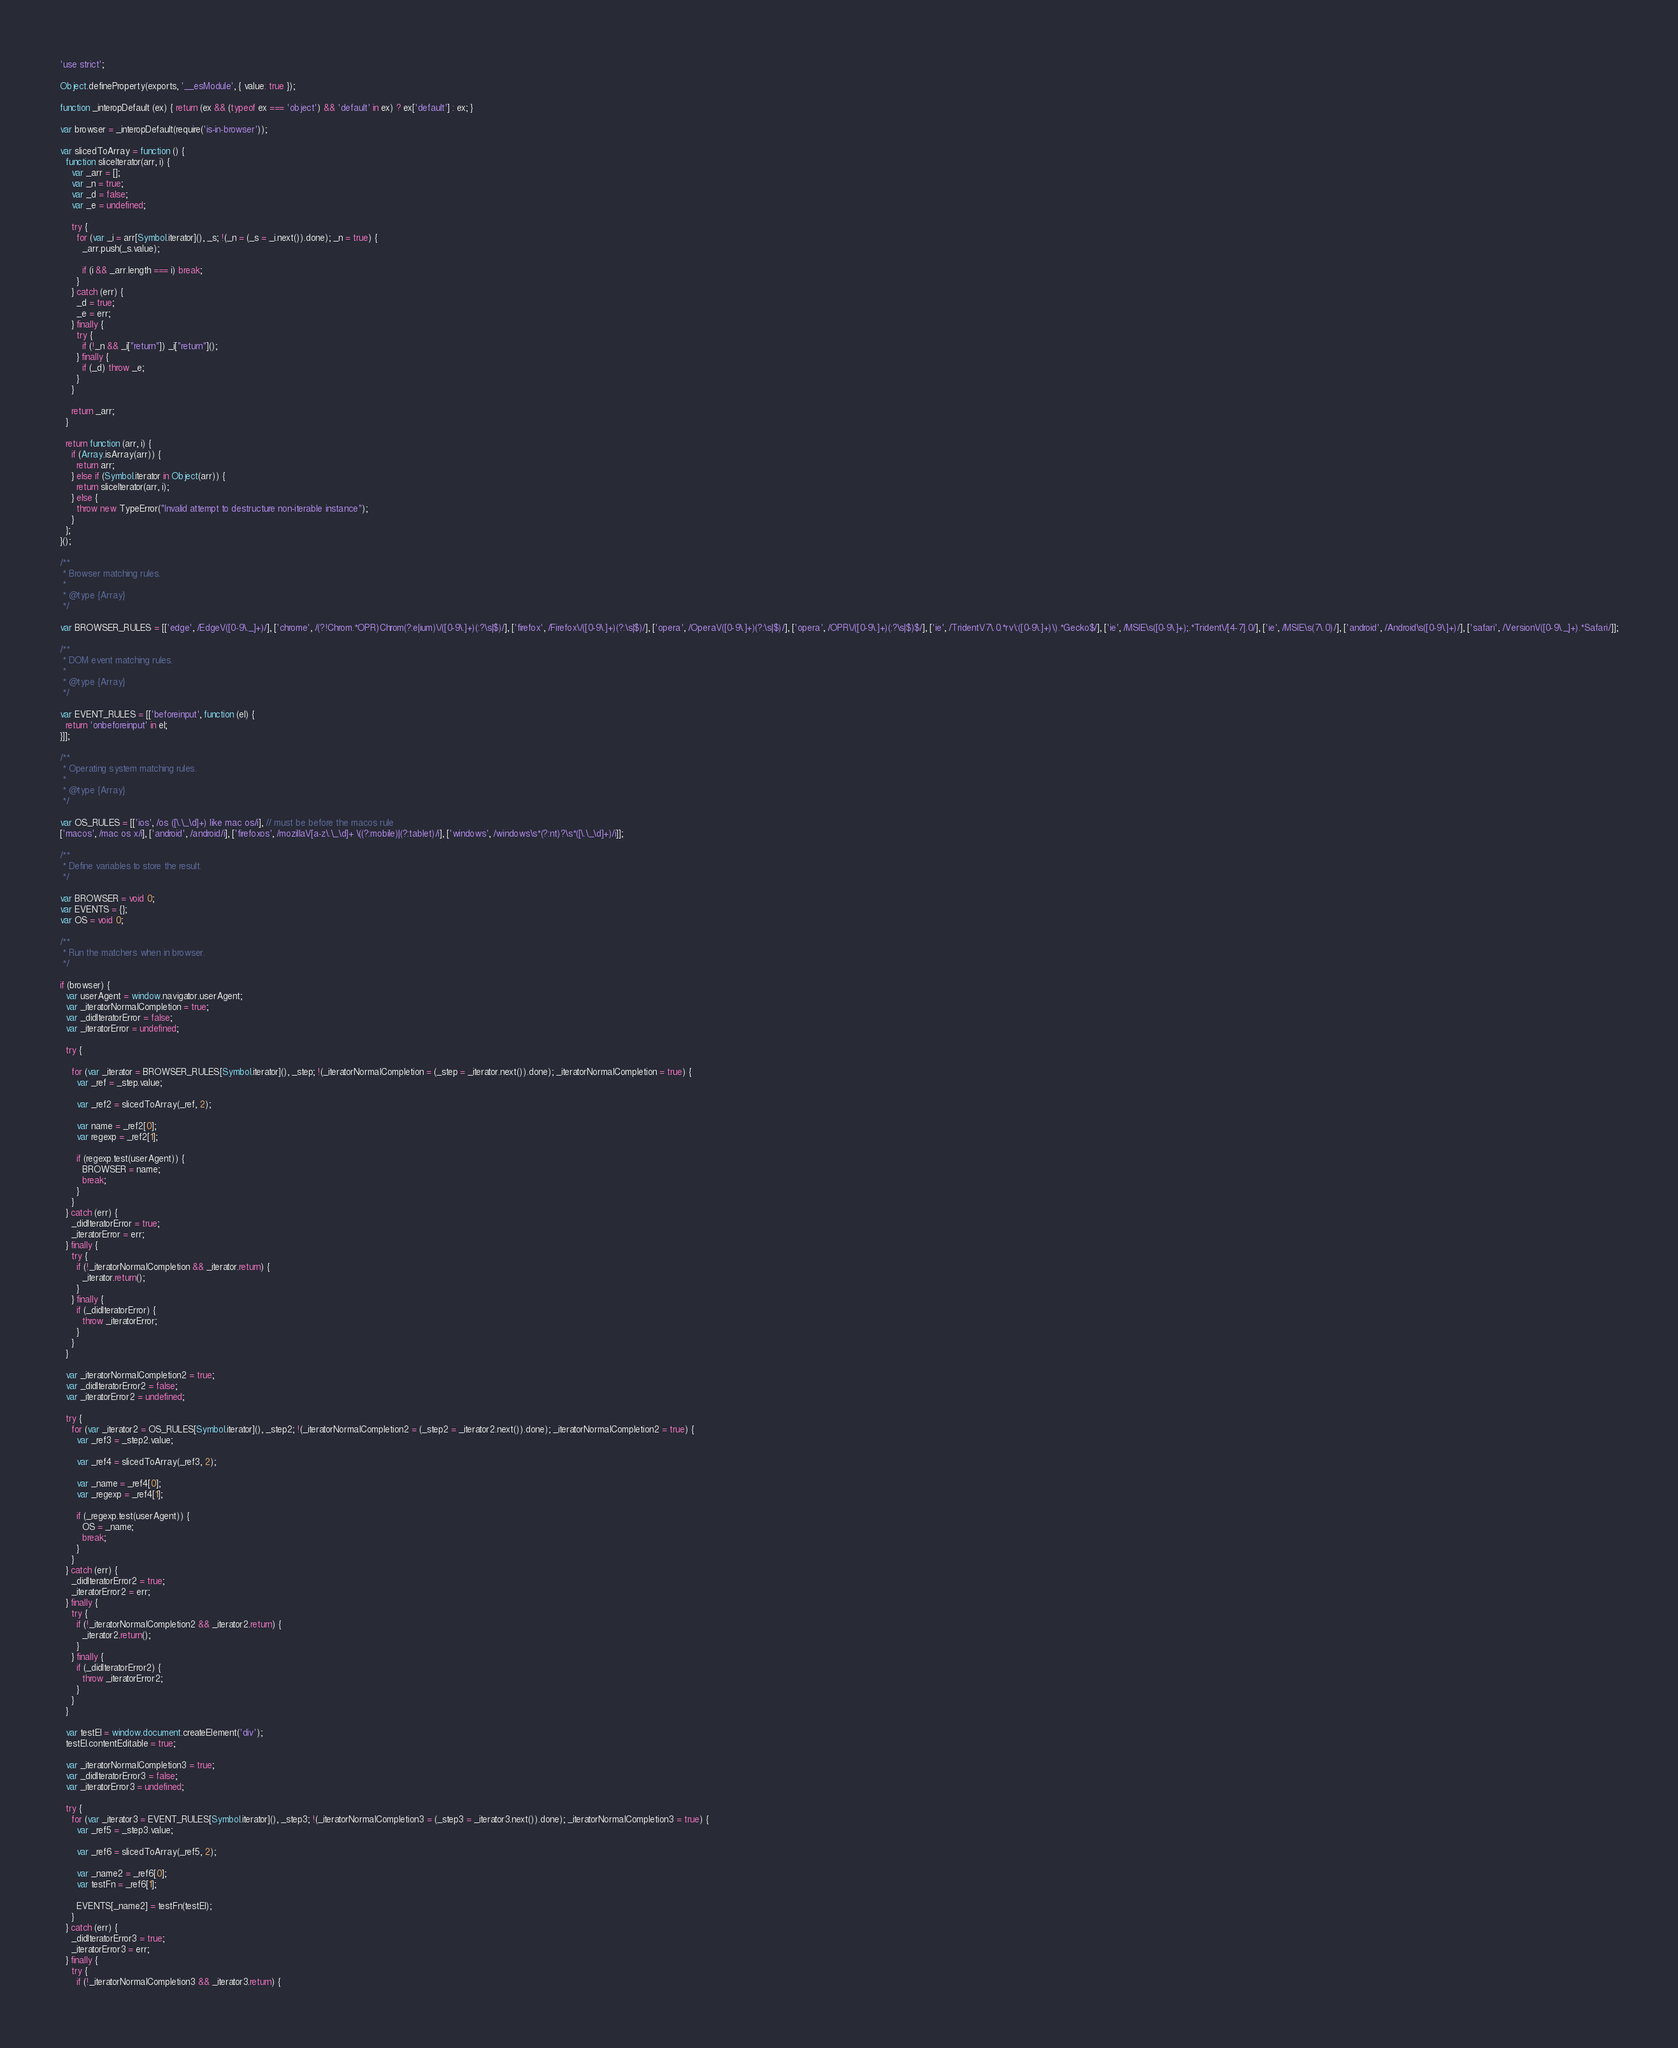<code> <loc_0><loc_0><loc_500><loc_500><_JavaScript_>'use strict';

Object.defineProperty(exports, '__esModule', { value: true });

function _interopDefault (ex) { return (ex && (typeof ex === 'object') && 'default' in ex) ? ex['default'] : ex; }

var browser = _interopDefault(require('is-in-browser'));

var slicedToArray = function () {
  function sliceIterator(arr, i) {
    var _arr = [];
    var _n = true;
    var _d = false;
    var _e = undefined;

    try {
      for (var _i = arr[Symbol.iterator](), _s; !(_n = (_s = _i.next()).done); _n = true) {
        _arr.push(_s.value);

        if (i && _arr.length === i) break;
      }
    } catch (err) {
      _d = true;
      _e = err;
    } finally {
      try {
        if (!_n && _i["return"]) _i["return"]();
      } finally {
        if (_d) throw _e;
      }
    }

    return _arr;
  }

  return function (arr, i) {
    if (Array.isArray(arr)) {
      return arr;
    } else if (Symbol.iterator in Object(arr)) {
      return sliceIterator(arr, i);
    } else {
      throw new TypeError("Invalid attempt to destructure non-iterable instance");
    }
  };
}();

/**
 * Browser matching rules.
 *
 * @type {Array}
 */

var BROWSER_RULES = [['edge', /Edge\/([0-9\._]+)/], ['chrome', /(?!Chrom.*OPR)Chrom(?:e|ium)\/([0-9\.]+)(:?\s|$)/], ['firefox', /Firefox\/([0-9\.]+)(?:\s|$)/], ['opera', /Opera\/([0-9\.]+)(?:\s|$)/], ['opera', /OPR\/([0-9\.]+)(:?\s|$)$/], ['ie', /Trident\/7\.0.*rv\:([0-9\.]+)\).*Gecko$/], ['ie', /MSIE\s([0-9\.]+);.*Trident\/[4-7].0/], ['ie', /MSIE\s(7\.0)/], ['android', /Android\s([0-9\.]+)/], ['safari', /Version\/([0-9\._]+).*Safari/]];

/**
 * DOM event matching rules.
 *
 * @type {Array}
 */

var EVENT_RULES = [['beforeinput', function (el) {
  return 'onbeforeinput' in el;
}]];

/**
 * Operating system matching rules.
 *
 * @type {Array}
 */

var OS_RULES = [['ios', /os ([\.\_\d]+) like mac os/i], // must be before the macos rule
['macos', /mac os x/i], ['android', /android/i], ['firefoxos', /mozilla\/[a-z\.\_\d]+ \((?:mobile)|(?:tablet)/i], ['windows', /windows\s*(?:nt)?\s*([\.\_\d]+)/i]];

/**
 * Define variables to store the result.
 */

var BROWSER = void 0;
var EVENTS = {};
var OS = void 0;

/**
 * Run the matchers when in browser.
 */

if (browser) {
  var userAgent = window.navigator.userAgent;
  var _iteratorNormalCompletion = true;
  var _didIteratorError = false;
  var _iteratorError = undefined;

  try {

    for (var _iterator = BROWSER_RULES[Symbol.iterator](), _step; !(_iteratorNormalCompletion = (_step = _iterator.next()).done); _iteratorNormalCompletion = true) {
      var _ref = _step.value;

      var _ref2 = slicedToArray(_ref, 2);

      var name = _ref2[0];
      var regexp = _ref2[1];

      if (regexp.test(userAgent)) {
        BROWSER = name;
        break;
      }
    }
  } catch (err) {
    _didIteratorError = true;
    _iteratorError = err;
  } finally {
    try {
      if (!_iteratorNormalCompletion && _iterator.return) {
        _iterator.return();
      }
    } finally {
      if (_didIteratorError) {
        throw _iteratorError;
      }
    }
  }

  var _iteratorNormalCompletion2 = true;
  var _didIteratorError2 = false;
  var _iteratorError2 = undefined;

  try {
    for (var _iterator2 = OS_RULES[Symbol.iterator](), _step2; !(_iteratorNormalCompletion2 = (_step2 = _iterator2.next()).done); _iteratorNormalCompletion2 = true) {
      var _ref3 = _step2.value;

      var _ref4 = slicedToArray(_ref3, 2);

      var _name = _ref4[0];
      var _regexp = _ref4[1];

      if (_regexp.test(userAgent)) {
        OS = _name;
        break;
      }
    }
  } catch (err) {
    _didIteratorError2 = true;
    _iteratorError2 = err;
  } finally {
    try {
      if (!_iteratorNormalCompletion2 && _iterator2.return) {
        _iterator2.return();
      }
    } finally {
      if (_didIteratorError2) {
        throw _iteratorError2;
      }
    }
  }

  var testEl = window.document.createElement('div');
  testEl.contentEditable = true;

  var _iteratorNormalCompletion3 = true;
  var _didIteratorError3 = false;
  var _iteratorError3 = undefined;

  try {
    for (var _iterator3 = EVENT_RULES[Symbol.iterator](), _step3; !(_iteratorNormalCompletion3 = (_step3 = _iterator3.next()).done); _iteratorNormalCompletion3 = true) {
      var _ref5 = _step3.value;

      var _ref6 = slicedToArray(_ref5, 2);

      var _name2 = _ref6[0];
      var testFn = _ref6[1];

      EVENTS[_name2] = testFn(testEl);
    }
  } catch (err) {
    _didIteratorError3 = true;
    _iteratorError3 = err;
  } finally {
    try {
      if (!_iteratorNormalCompletion3 && _iterator3.return) {</code> 